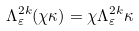<formula> <loc_0><loc_0><loc_500><loc_500>\Lambda ^ { 2 k } _ { \varepsilon } ( \chi \kappa ) = \chi \Lambda ^ { 2 k } _ { \varepsilon } \kappa</formula> 